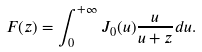Convert formula to latex. <formula><loc_0><loc_0><loc_500><loc_500>F ( z ) = \int _ { 0 } ^ { + \infty } J _ { 0 } ( u ) \frac { u } { u + z } d u .</formula> 